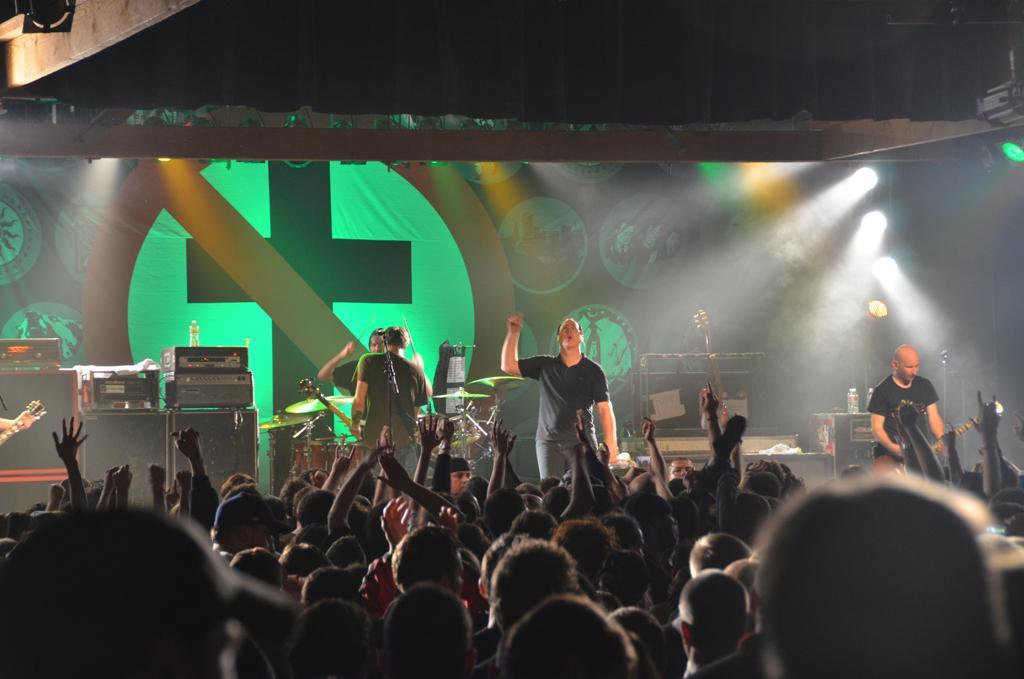In one or two sentences, can you explain what this image depicts? Here we can see a group of people performing on a stage with lots of musical instruments and microphones on the stage and in front of them there are a large number of audiences who are enjoying their music and here and there there are some lights colorful lights 